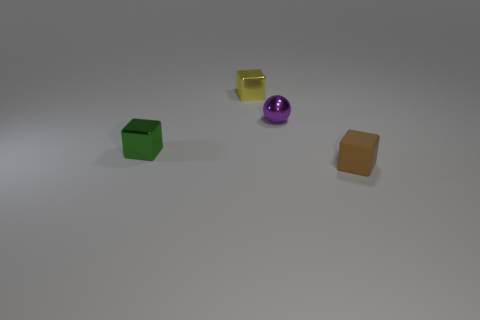Subtract all green cubes. How many cubes are left? 2 Add 2 tiny yellow blocks. How many objects exist? 6 Subtract all balls. How many objects are left? 3 Subtract all brown matte objects. Subtract all gray blocks. How many objects are left? 3 Add 4 tiny yellow cubes. How many tiny yellow cubes are left? 5 Add 1 small blocks. How many small blocks exist? 4 Subtract 0 brown cylinders. How many objects are left? 4 